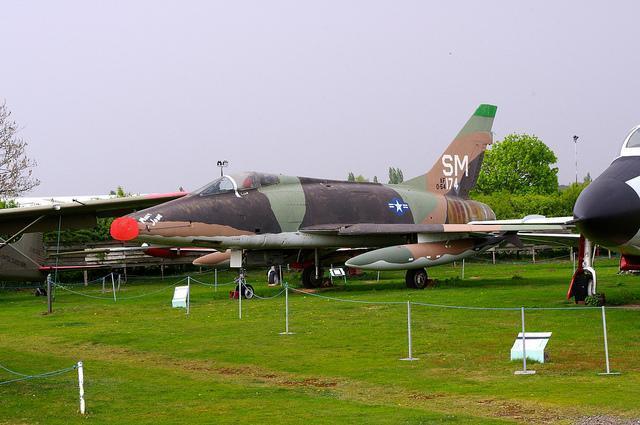How many airplanes are there?
Give a very brief answer. 3. 